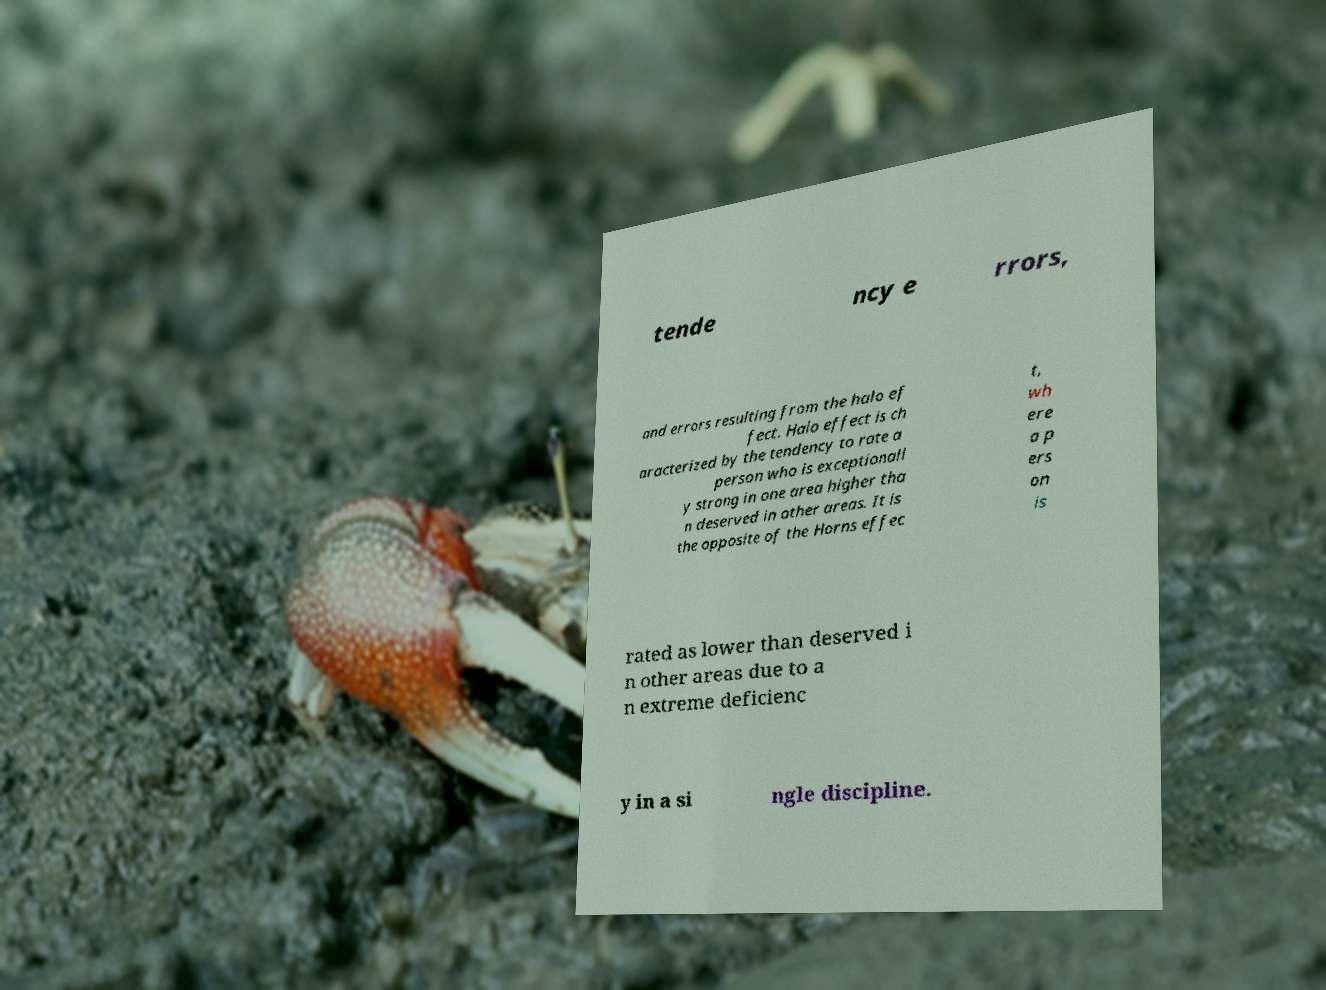Can you accurately transcribe the text from the provided image for me? tende ncy e rrors, and errors resulting from the halo ef fect. Halo effect is ch aracterized by the tendency to rate a person who is exceptionall y strong in one area higher tha n deserved in other areas. It is the opposite of the Horns effec t, wh ere a p ers on is rated as lower than deserved i n other areas due to a n extreme deficienc y in a si ngle discipline. 